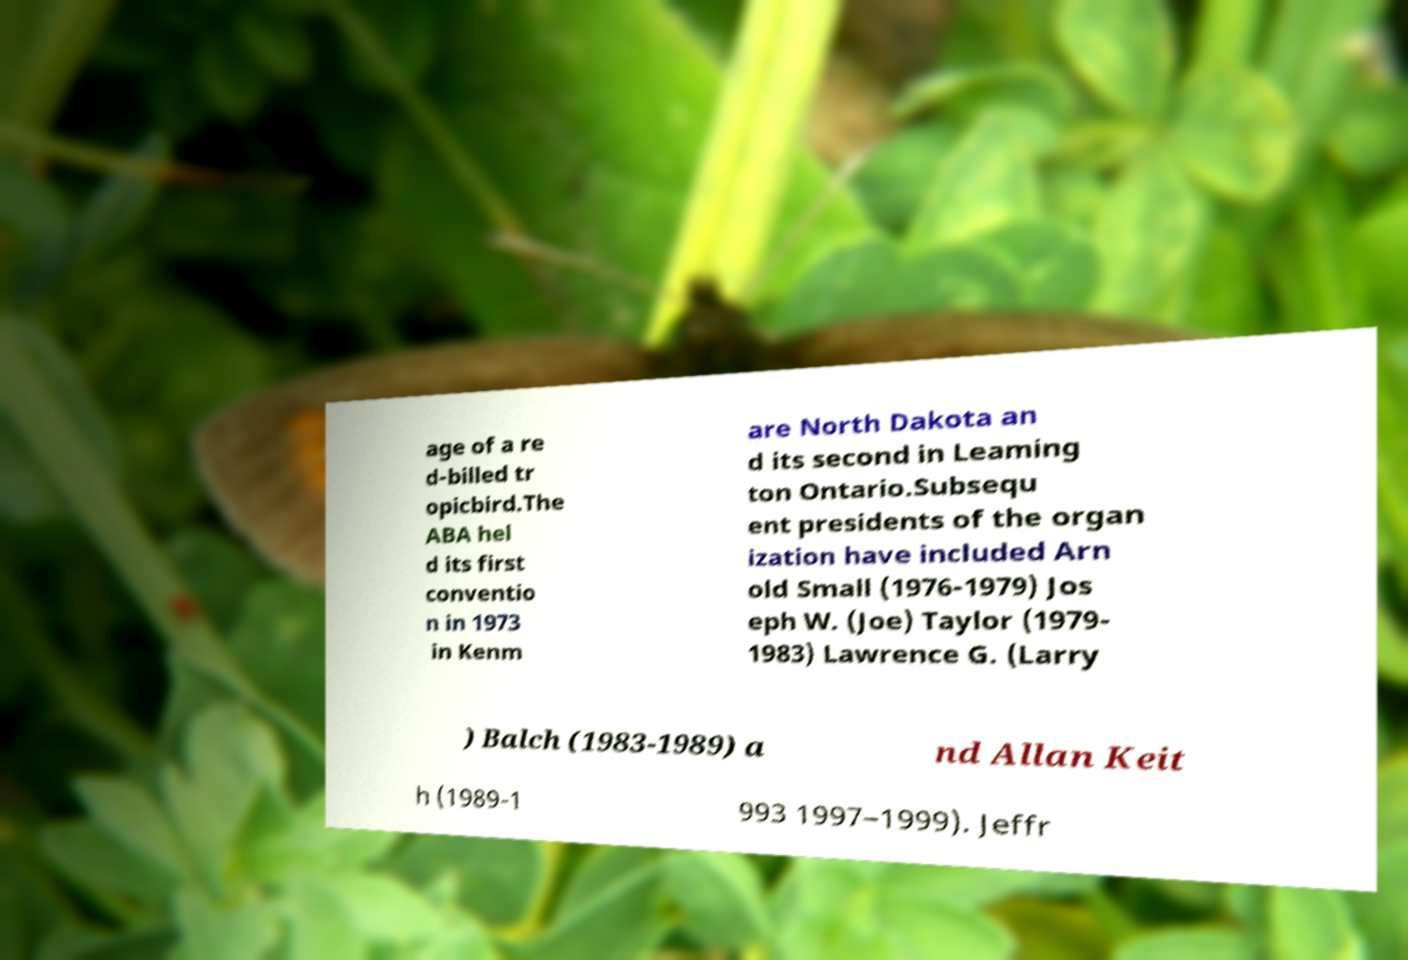Please identify and transcribe the text found in this image. age of a re d-billed tr opicbird.The ABA hel d its first conventio n in 1973 in Kenm are North Dakota an d its second in Leaming ton Ontario.Subsequ ent presidents of the organ ization have included Arn old Small (1976-1979) Jos eph W. (Joe) Taylor (1979- 1983) Lawrence G. (Larry ) Balch (1983-1989) a nd Allan Keit h (1989-1 993 1997–1999). Jeffr 